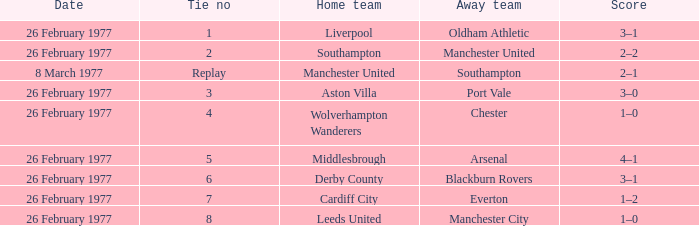What's the score when the tie number was 6? 3–1. 